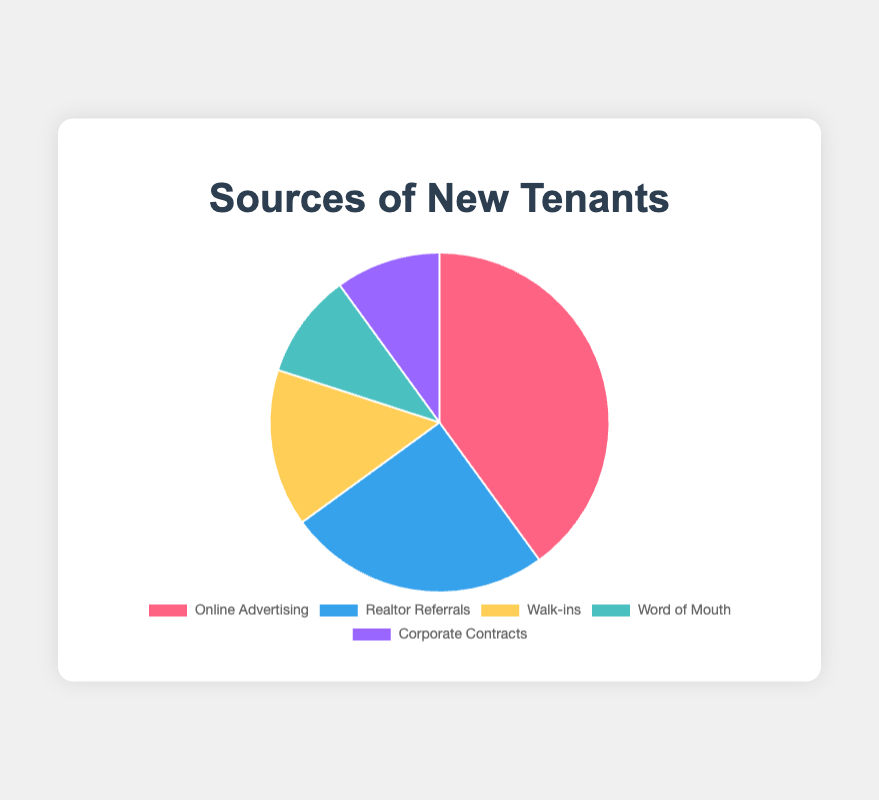What percentage of new tenants come from Online Advertising compared to Word of Mouth? Online Advertising contributes 40% while Word of Mouth contributes 10%, so Online Advertising has a higher percentage by 40% - 10% = 30%
Answer: 30% Which source brings in the most new tenants? The source with the highest percentage is Online Advertising at 40%
Answer: Online Advertising What is the combined percentage of new tenants from Walk-ins and Corporate Contracts? Walk-ins account for 15% and Corporate Contracts account for 10%, so the combined percentage is 15% + 10% = 25%
Answer: 25% What percentage of new tenants come from Realtor Referrals and how does it compare to Corporate Contracts? Realtor Referrals account for 25% while Corporate Contracts account for 10%. Realtor Referrals contribute 15% more
Answer: 15% What is the least common source of new tenants? Word of Mouth and Corporate Contracts both account for the lowest percentage at 10% each
Answer: Word of Mouth and Corporate Contracts What percentage do Word of Mouth and Walk-ins collectively contribute? Word of Mouth contributes 10% and Walk-ins contribute 15%, so collectively they contribute 10% + 15% = 25%
Answer: 25% Which source of new tenants has a blue section in the pie chart? Realtor Referrals has a blue section in the pie chart
Answer: Realtor Referrals 